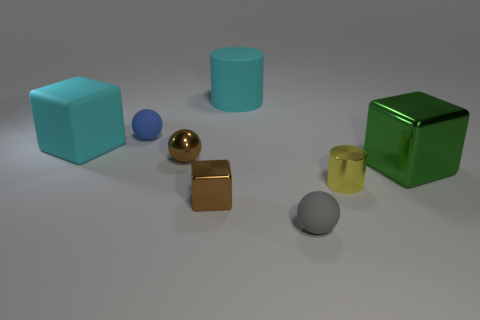Subtract 1 cubes. How many cubes are left? 2 Add 1 small cubes. How many objects exist? 9 Subtract all blocks. How many objects are left? 5 Subtract 0 red cylinders. How many objects are left? 8 Subtract all big matte objects. Subtract all small brown things. How many objects are left? 4 Add 3 big cyan blocks. How many big cyan blocks are left? 4 Add 6 tiny green metallic objects. How many tiny green metallic objects exist? 6 